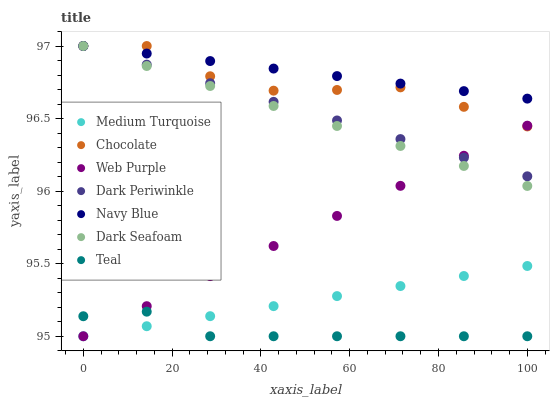Does Teal have the minimum area under the curve?
Answer yes or no. Yes. Does Navy Blue have the maximum area under the curve?
Answer yes or no. Yes. Does Web Purple have the minimum area under the curve?
Answer yes or no. No. Does Web Purple have the maximum area under the curve?
Answer yes or no. No. Is Dark Seafoam the smoothest?
Answer yes or no. Yes. Is Chocolate the roughest?
Answer yes or no. Yes. Is Navy Blue the smoothest?
Answer yes or no. No. Is Navy Blue the roughest?
Answer yes or no. No. Does Teal have the lowest value?
Answer yes or no. Yes. Does Navy Blue have the lowest value?
Answer yes or no. No. Does Dark Periwinkle have the highest value?
Answer yes or no. Yes. Does Web Purple have the highest value?
Answer yes or no. No. Is Medium Turquoise less than Chocolate?
Answer yes or no. Yes. Is Navy Blue greater than Web Purple?
Answer yes or no. Yes. Does Dark Periwinkle intersect Chocolate?
Answer yes or no. Yes. Is Dark Periwinkle less than Chocolate?
Answer yes or no. No. Is Dark Periwinkle greater than Chocolate?
Answer yes or no. No. Does Medium Turquoise intersect Chocolate?
Answer yes or no. No. 